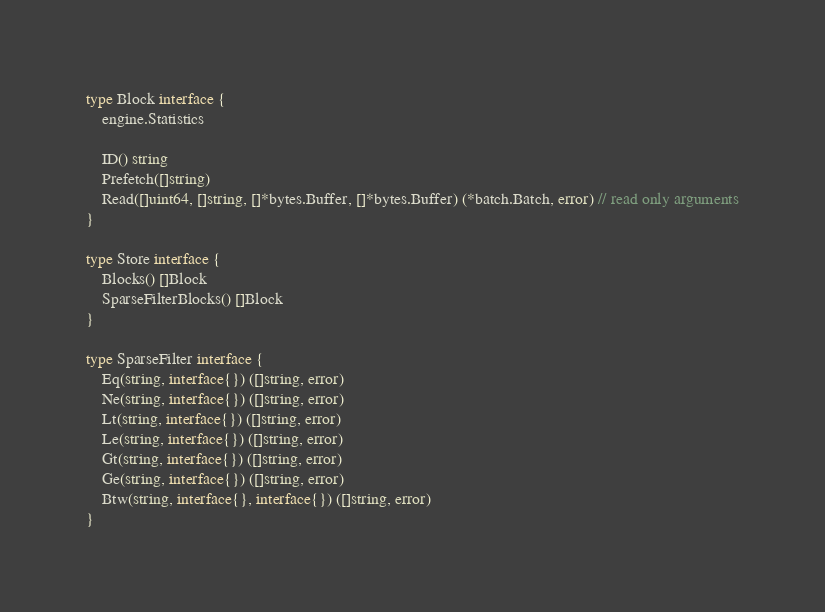<code> <loc_0><loc_0><loc_500><loc_500><_Go_>type Block interface {
	engine.Statistics

	ID() string
	Prefetch([]string)
	Read([]uint64, []string, []*bytes.Buffer, []*bytes.Buffer) (*batch.Batch, error) // read only arguments
}

type Store interface {
	Blocks() []Block
	SparseFilterBlocks() []Block
}

type SparseFilter interface {
	Eq(string, interface{}) ([]string, error)
	Ne(string, interface{}) ([]string, error)
	Lt(string, interface{}) ([]string, error)
	Le(string, interface{}) ([]string, error)
	Gt(string, interface{}) ([]string, error)
	Ge(string, interface{}) ([]string, error)
	Btw(string, interface{}, interface{}) ([]string, error)
}</code> 